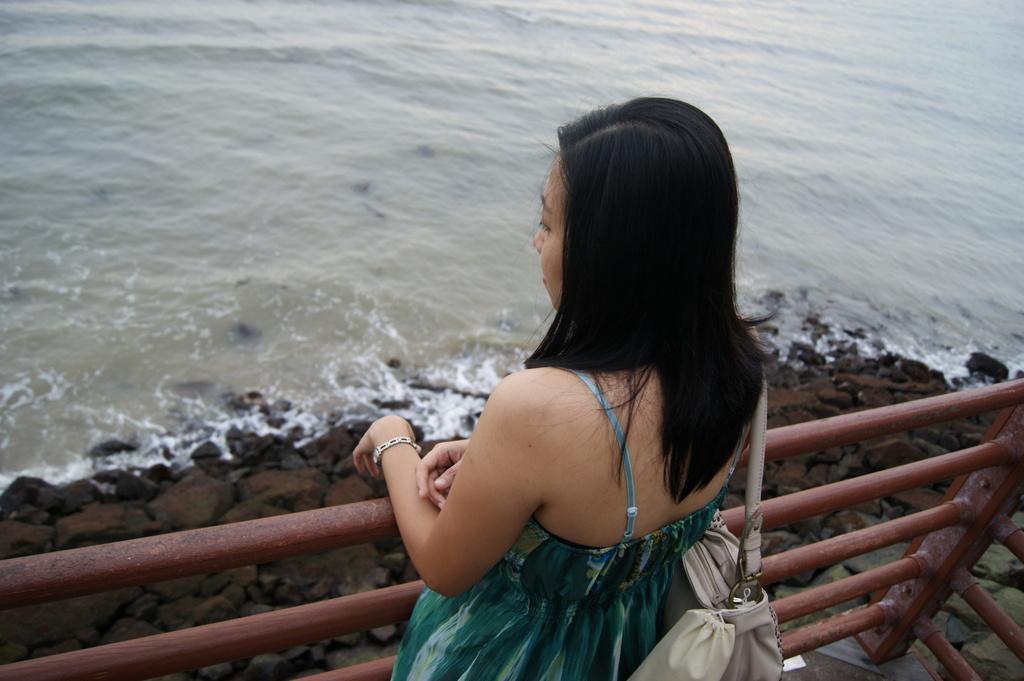Could you give a brief overview of what you see in this image? In this image we can see a woman is standing, she is wearing the bag, here is the metal rod, here are the rocks, here is the water. 